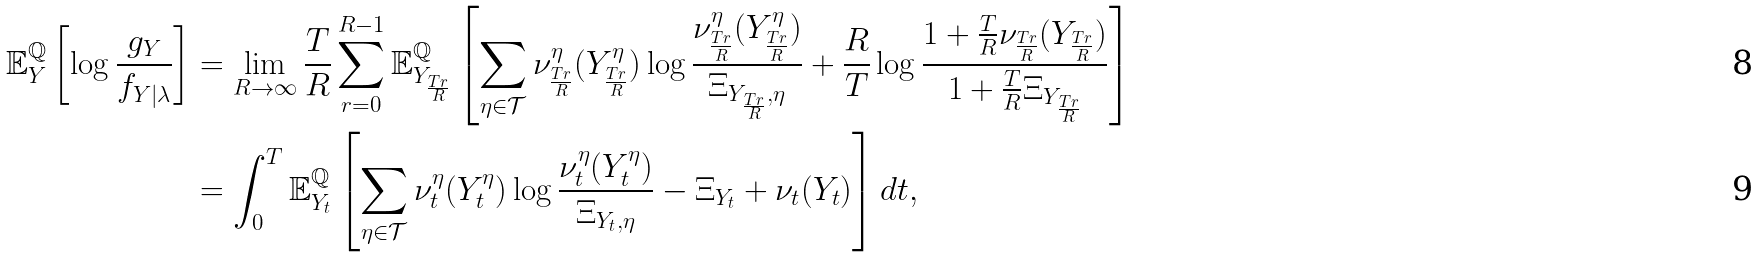Convert formula to latex. <formula><loc_0><loc_0><loc_500><loc_500>\mathbb { E } ^ { \mathbb { Q } } _ { Y } \left [ \log \frac { g _ { Y } } { f _ { Y | \lambda } } \right ] & = \lim _ { R \rightarrow \infty } \frac { T } { R } \sum _ { r = 0 } ^ { R - 1 } \mathbb { E } ^ { \mathbb { Q } } _ { Y _ { \frac { T r } { R } } } \left [ \sum _ { { \eta } \in \mathcal { T } } \nu ^ { \eta } _ { \frac { T r } { R } } ( Y ^ { \eta } _ { \frac { T r } { R } } ) \log \frac { \nu ^ { \eta } _ { \frac { T r } { R } } ( Y ^ { \eta } _ { \frac { T r } { R } } ) } { \Xi _ { Y _ { \frac { T r } { R } } , { \eta } } } + \frac { R } { T } \log \frac { 1 + \frac { T } { R } \nu _ { \frac { T r } { R } } ( Y _ { \frac { T r } { R } } ) } { 1 + \frac { T } { R } \Xi _ { Y _ { \frac { T r } { R } } } } \right ] \\ & = \int _ { 0 } ^ { T } \mathbb { E } ^ { \mathbb { Q } } _ { Y _ { t } } \left [ \sum _ { { \eta } \in \mathcal { T } } \nu ^ { \eta } _ { t } ( Y ^ { \eta } _ { t } ) \log \frac { \nu ^ { \eta } _ { t } ( Y ^ { \eta } _ { t } ) } { \Xi _ { Y _ { t } , { \eta } } } - \Xi _ { Y _ { t } } + \nu _ { t } ( Y _ { t } ) \right ] d t ,</formula> 